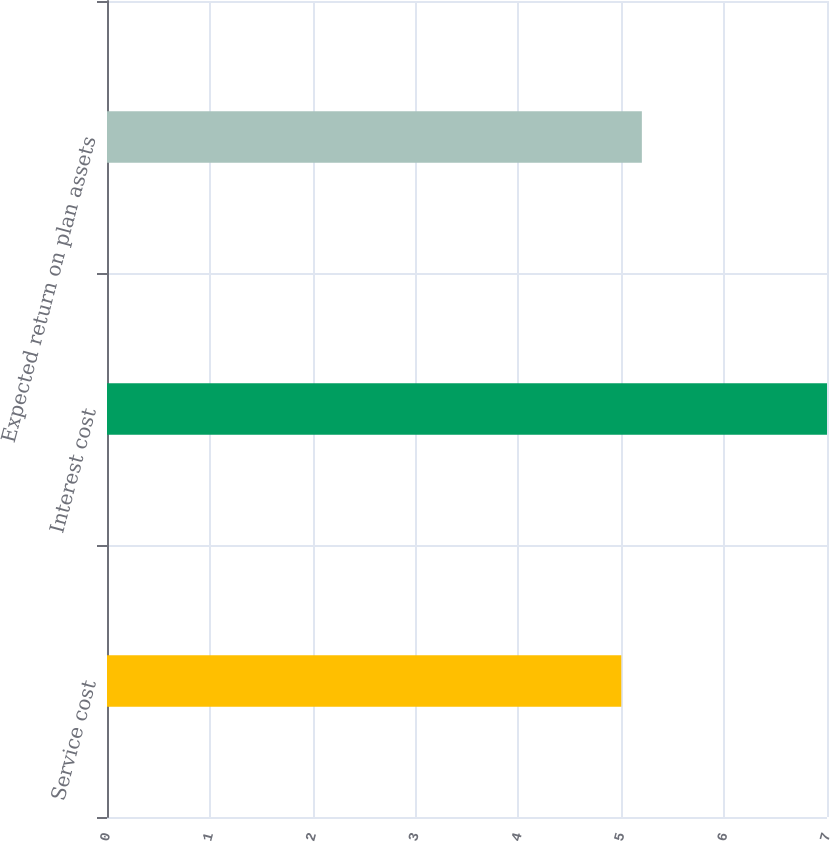Convert chart. <chart><loc_0><loc_0><loc_500><loc_500><bar_chart><fcel>Service cost<fcel>Interest cost<fcel>Expected return on plan assets<nl><fcel>5<fcel>7<fcel>5.2<nl></chart> 